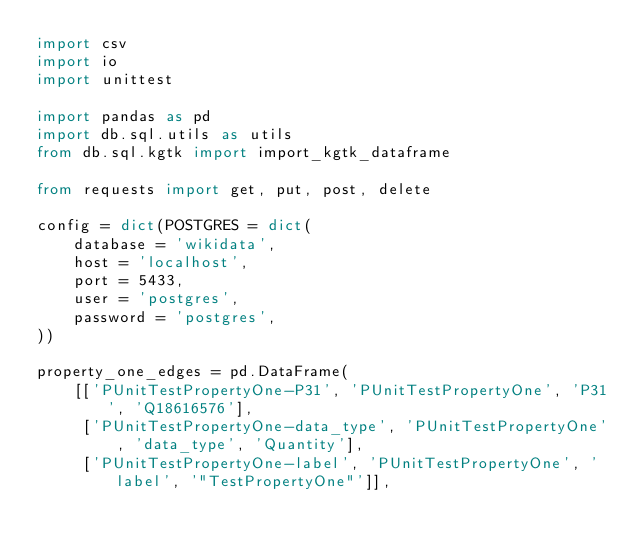Convert code to text. <code><loc_0><loc_0><loc_500><loc_500><_Python_>import csv
import io
import unittest

import pandas as pd
import db.sql.utils as utils
from db.sql.kgtk import import_kgtk_dataframe

from requests import get, put, post, delete

config = dict(POSTGRES = dict(
    database = 'wikidata',
    host = 'localhost',
    port = 5433,
    user = 'postgres',
    password = 'postgres',
))

property_one_edges = pd.DataFrame(
    [['PUnitTestPropertyOne-P31', 'PUnitTestPropertyOne', 'P31', 'Q18616576'],
     ['PUnitTestPropertyOne-data_type', 'PUnitTestPropertyOne', 'data_type', 'Quantity'],
     ['PUnitTestPropertyOne-label', 'PUnitTestPropertyOne', 'label', '"TestPropertyOne"']],</code> 